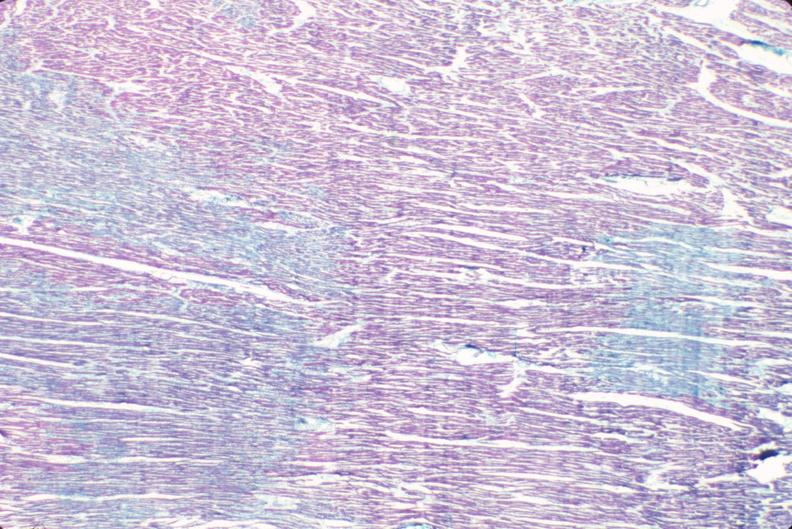what is present?
Answer the question using a single word or phrase. Cardiovascular 